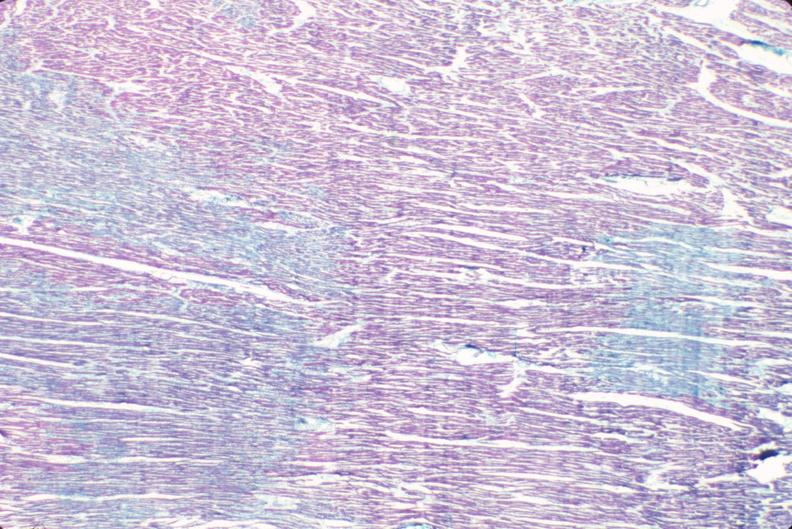what is present?
Answer the question using a single word or phrase. Cardiovascular 